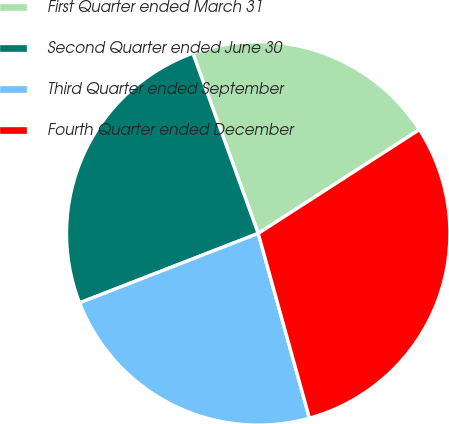<chart> <loc_0><loc_0><loc_500><loc_500><pie_chart><fcel>First Quarter ended March 31<fcel>Second Quarter ended June 30<fcel>Third Quarter ended September<fcel>Fourth Quarter ended December<nl><fcel>21.43%<fcel>25.36%<fcel>23.4%<fcel>29.8%<nl></chart> 